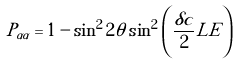Convert formula to latex. <formula><loc_0><loc_0><loc_500><loc_500>P _ { \alpha \alpha } = 1 - \sin ^ { 2 } 2 \theta \sin ^ { 2 } \left ( \frac { \delta c } { 2 } L E \right )</formula> 